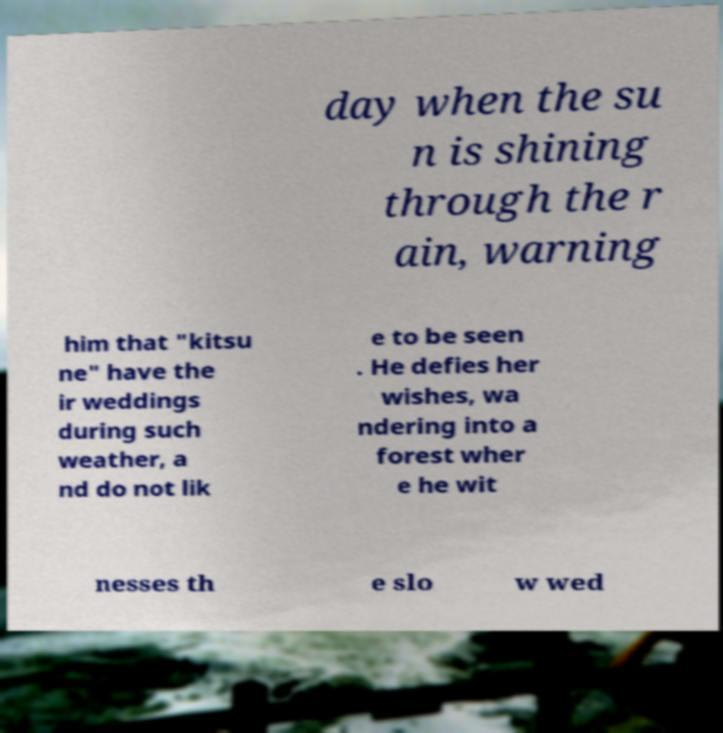Could you assist in decoding the text presented in this image and type it out clearly? day when the su n is shining through the r ain, warning him that "kitsu ne" have the ir weddings during such weather, a nd do not lik e to be seen . He defies her wishes, wa ndering into a forest wher e he wit nesses th e slo w wed 